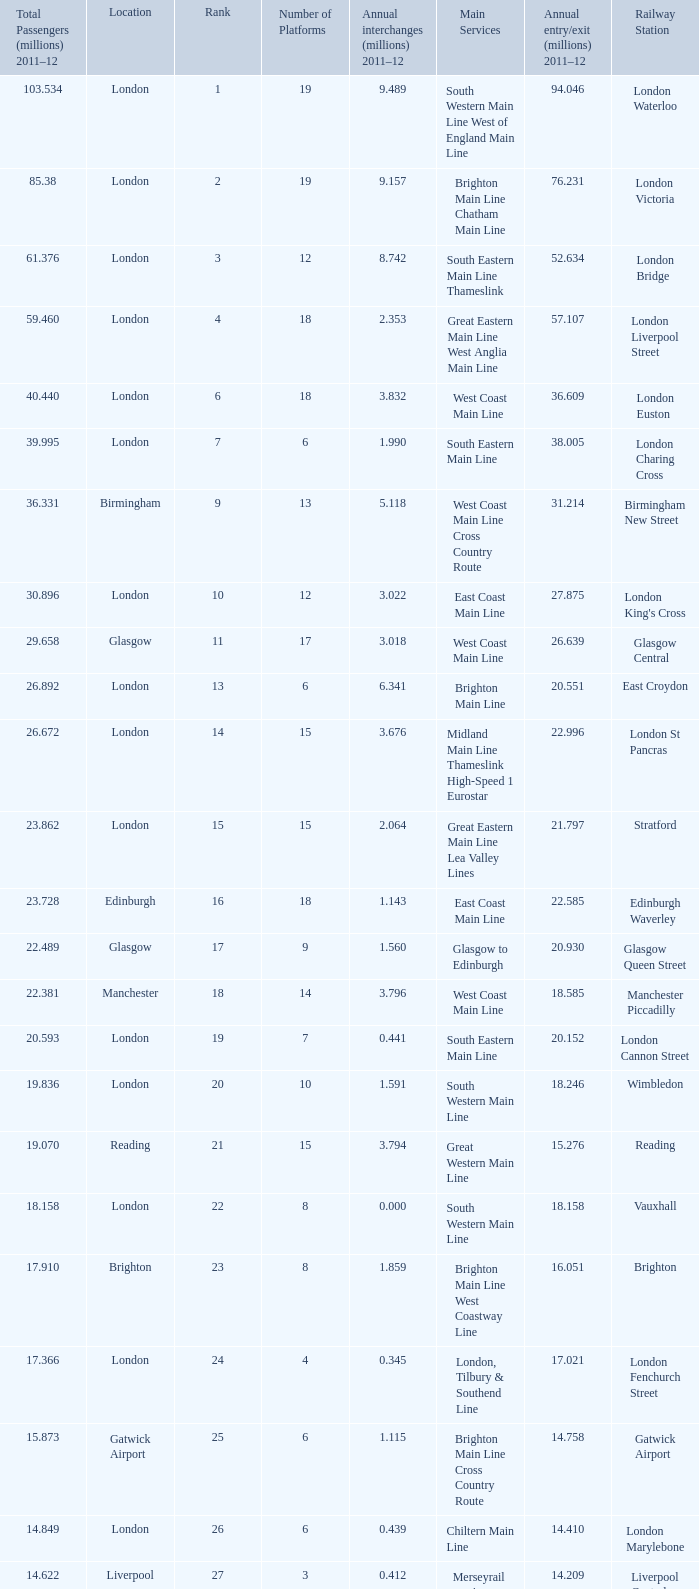What is the lowest rank of Gatwick Airport?  25.0. 